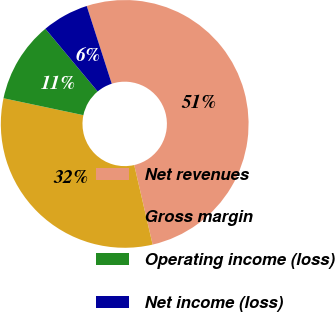Convert chart to OTSL. <chart><loc_0><loc_0><loc_500><loc_500><pie_chart><fcel>Net revenues<fcel>Gross margin<fcel>Operating income (loss)<fcel>Net income (loss)<nl><fcel>51.34%<fcel>31.94%<fcel>10.62%<fcel>6.1%<nl></chart> 